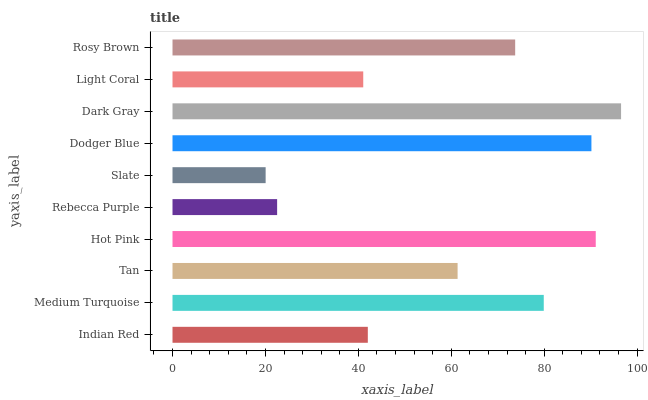Is Slate the minimum?
Answer yes or no. Yes. Is Dark Gray the maximum?
Answer yes or no. Yes. Is Medium Turquoise the minimum?
Answer yes or no. No. Is Medium Turquoise the maximum?
Answer yes or no. No. Is Medium Turquoise greater than Indian Red?
Answer yes or no. Yes. Is Indian Red less than Medium Turquoise?
Answer yes or no. Yes. Is Indian Red greater than Medium Turquoise?
Answer yes or no. No. Is Medium Turquoise less than Indian Red?
Answer yes or no. No. Is Rosy Brown the high median?
Answer yes or no. Yes. Is Tan the low median?
Answer yes or no. Yes. Is Hot Pink the high median?
Answer yes or no. No. Is Hot Pink the low median?
Answer yes or no. No. 